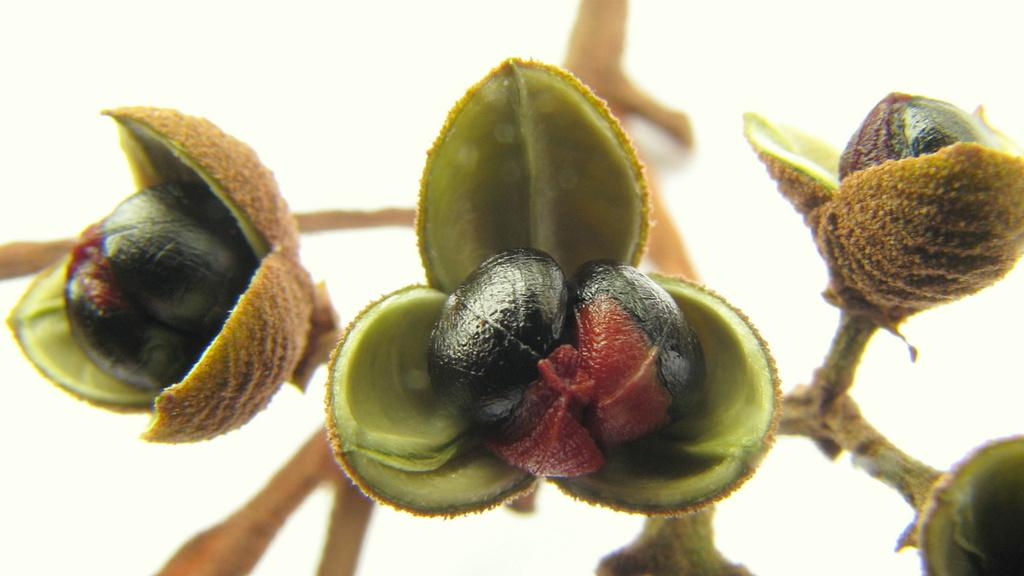What type of plant life is present in the image? There are buds in the image. What colors are the buds? The buds are black and red in color. How are the buds connected to the tree? The buds are attached to a tree. What colors are the tree? The tree is brown and green in color. What color is the background of the image? The background of the image is white. How many friends are sitting on the point in the image? There are no friends or points present in the image; it features buds attached to a tree with a white background. 